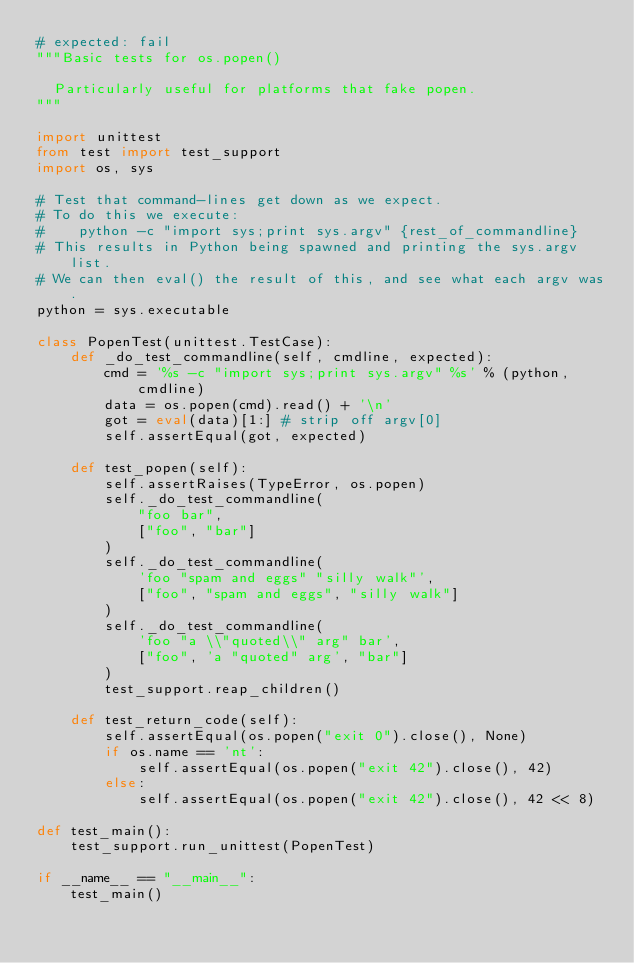Convert code to text. <code><loc_0><loc_0><loc_500><loc_500><_Python_># expected: fail
"""Basic tests for os.popen()

  Particularly useful for platforms that fake popen.
"""

import unittest
from test import test_support
import os, sys

# Test that command-lines get down as we expect.
# To do this we execute:
#    python -c "import sys;print sys.argv" {rest_of_commandline}
# This results in Python being spawned and printing the sys.argv list.
# We can then eval() the result of this, and see what each argv was.
python = sys.executable

class PopenTest(unittest.TestCase):
    def _do_test_commandline(self, cmdline, expected):
        cmd = '%s -c "import sys;print sys.argv" %s' % (python, cmdline)
        data = os.popen(cmd).read() + '\n'
        got = eval(data)[1:] # strip off argv[0]
        self.assertEqual(got, expected)

    def test_popen(self):
        self.assertRaises(TypeError, os.popen)
        self._do_test_commandline(
            "foo bar",
            ["foo", "bar"]
        )
        self._do_test_commandline(
            'foo "spam and eggs" "silly walk"',
            ["foo", "spam and eggs", "silly walk"]
        )
        self._do_test_commandline(
            'foo "a \\"quoted\\" arg" bar',
            ["foo", 'a "quoted" arg', "bar"]
        )
        test_support.reap_children()

    def test_return_code(self):
        self.assertEqual(os.popen("exit 0").close(), None)
        if os.name == 'nt':
            self.assertEqual(os.popen("exit 42").close(), 42)
        else:
            self.assertEqual(os.popen("exit 42").close(), 42 << 8)

def test_main():
    test_support.run_unittest(PopenTest)

if __name__ == "__main__":
    test_main()
</code> 